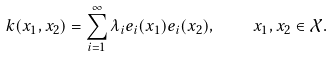Convert formula to latex. <formula><loc_0><loc_0><loc_500><loc_500>k ( x _ { 1 } , x _ { 2 } ) = \sum _ { i = 1 } ^ { \infty } \lambda _ { i } e _ { i } ( x _ { 1 } ) e _ { i } ( x _ { 2 } ) , \quad x _ { 1 } , x _ { 2 } \in \mathcal { X } .</formula> 